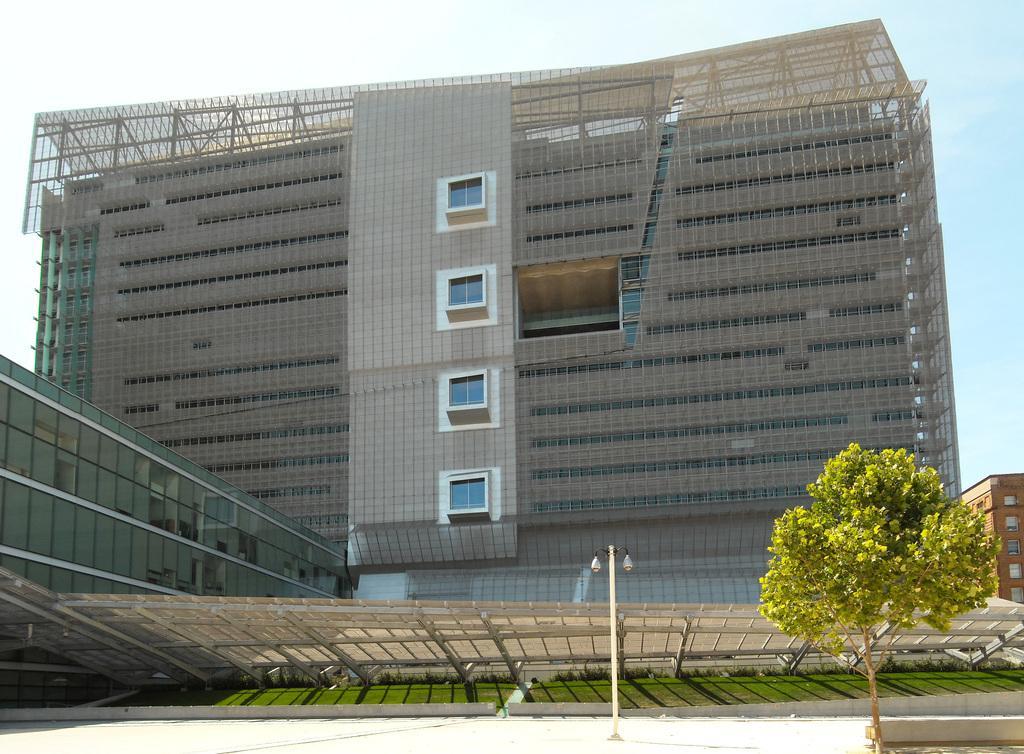Describe this image in one or two sentences. In this image we can see some buildings with windows. On the bottom of the image we can see some plants and grass under a roof, a street pole, a tree and the sky which looks cloudy. 